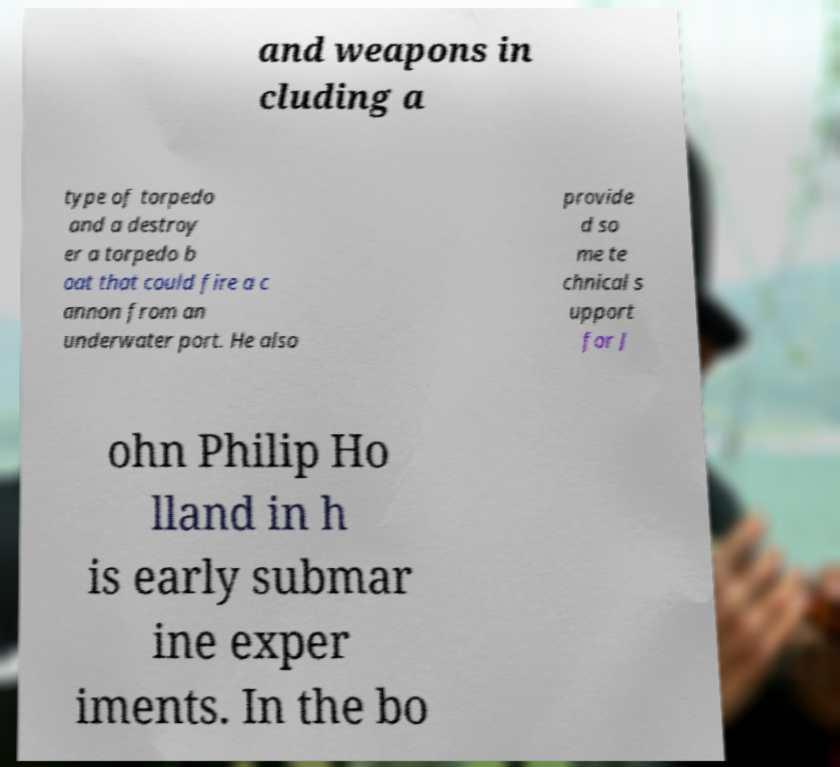Could you extract and type out the text from this image? and weapons in cluding a type of torpedo and a destroy er a torpedo b oat that could fire a c annon from an underwater port. He also provide d so me te chnical s upport for J ohn Philip Ho lland in h is early submar ine exper iments. In the bo 